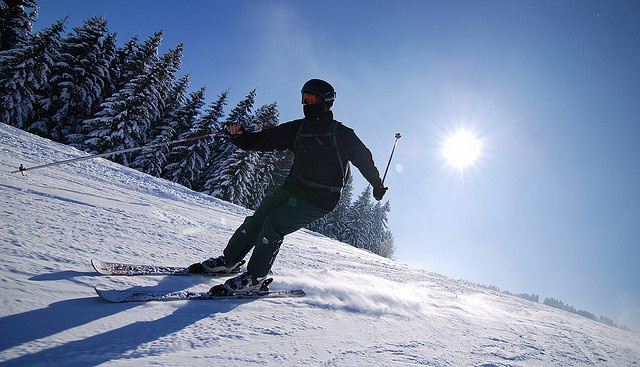Describe the objects in this image and their specific colors. I can see people in navy, black, lightgray, darkgray, and gray tones and skis in navy, black, darkblue, and darkgray tones in this image. 